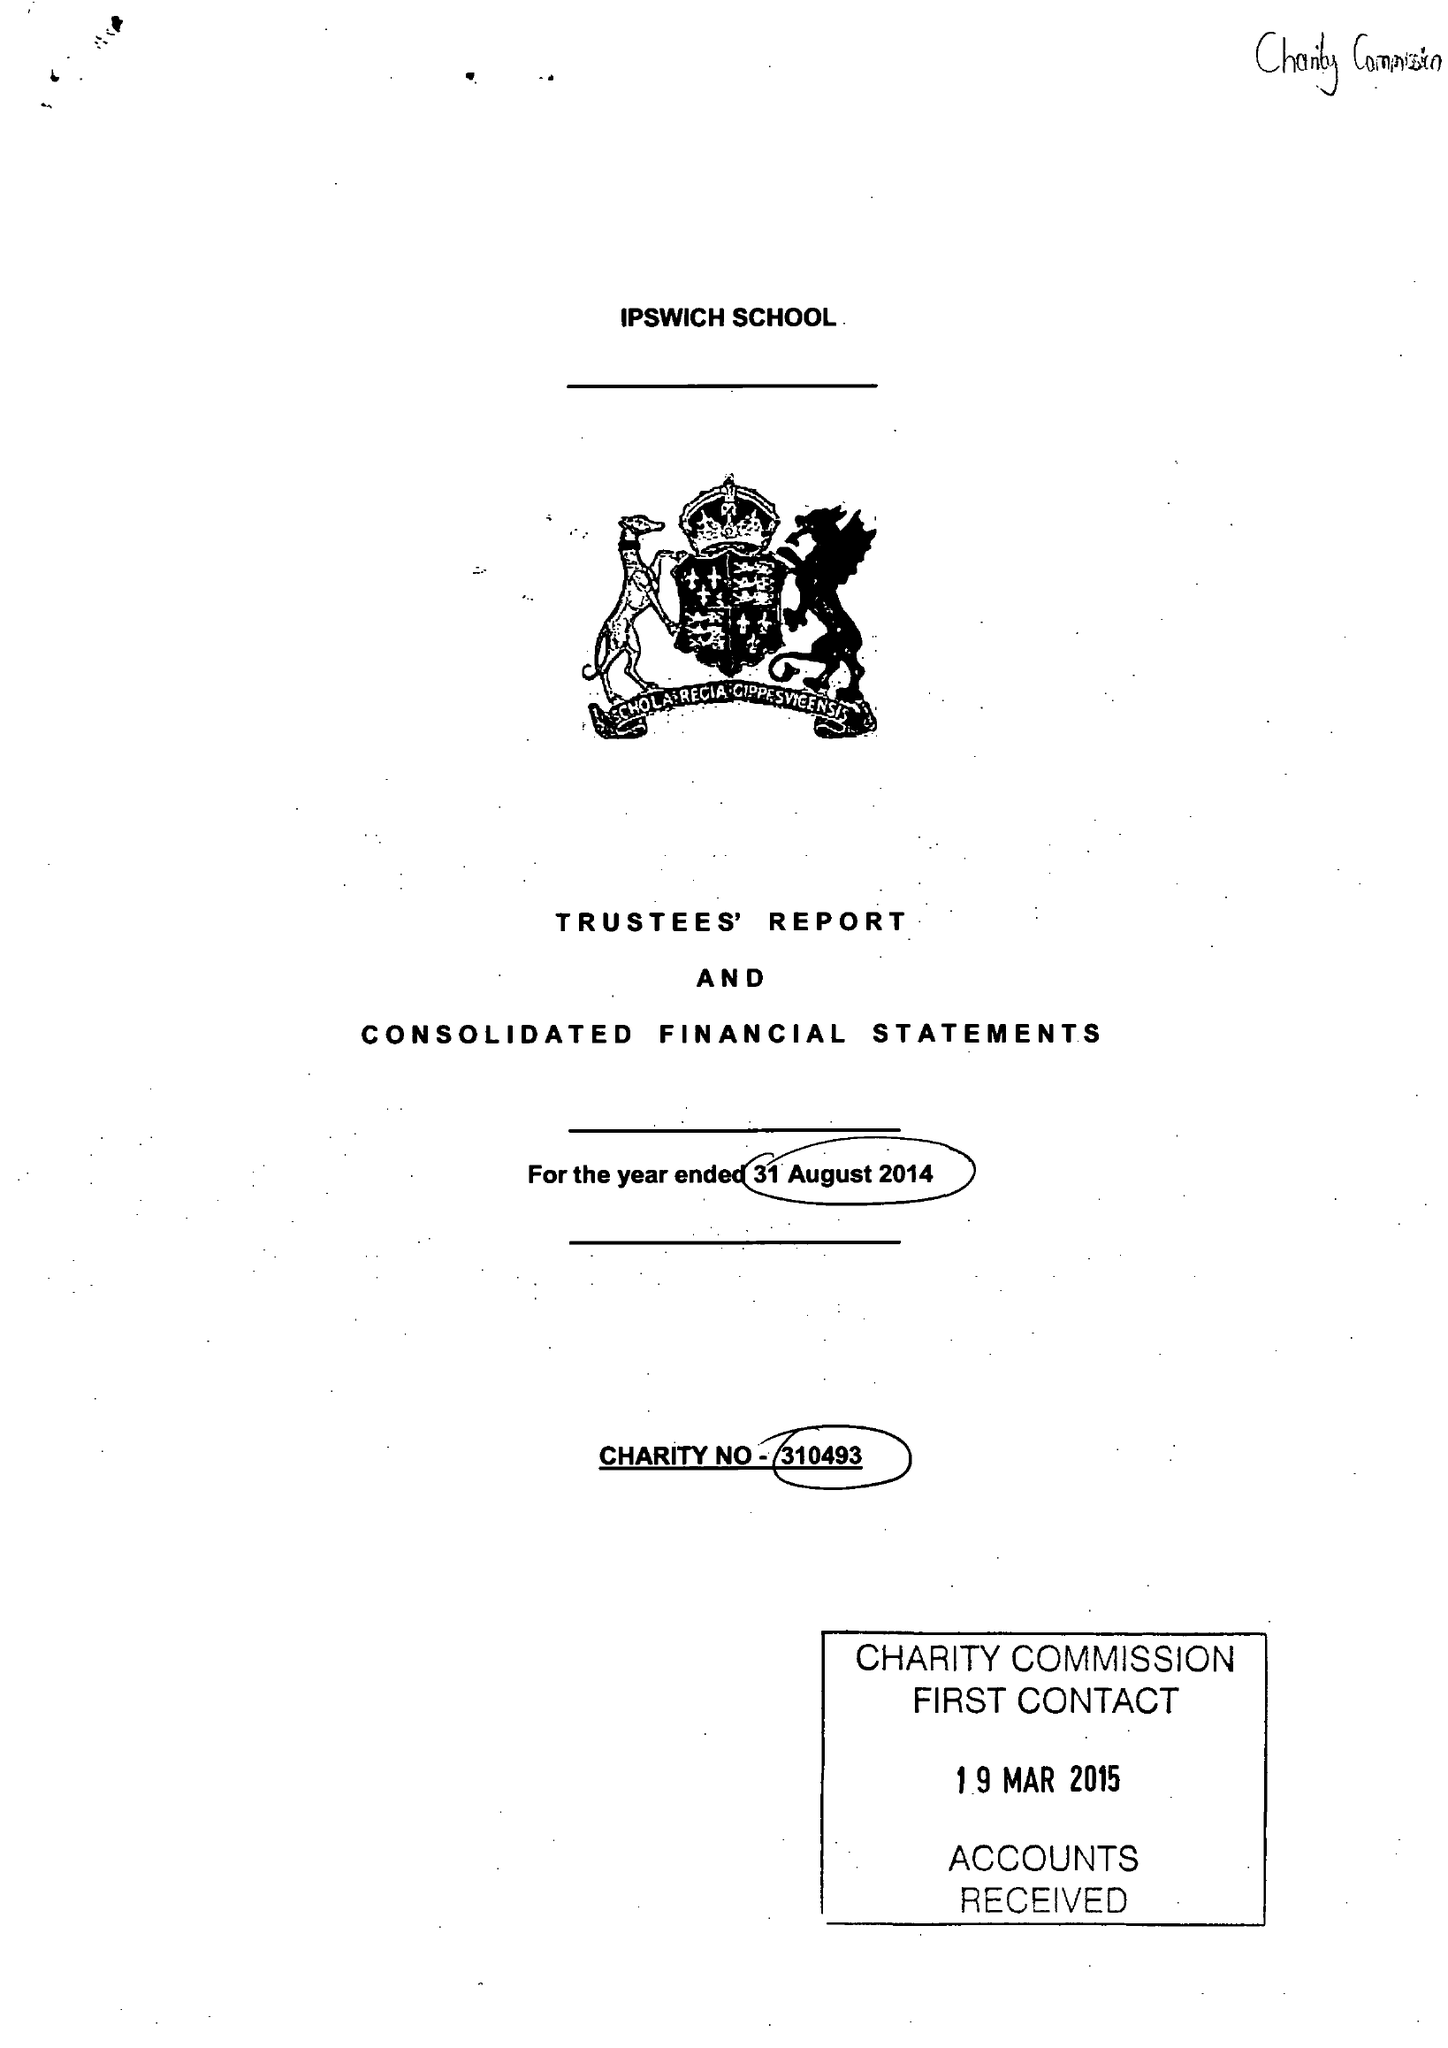What is the value for the charity_number?
Answer the question using a single word or phrase. 310493 